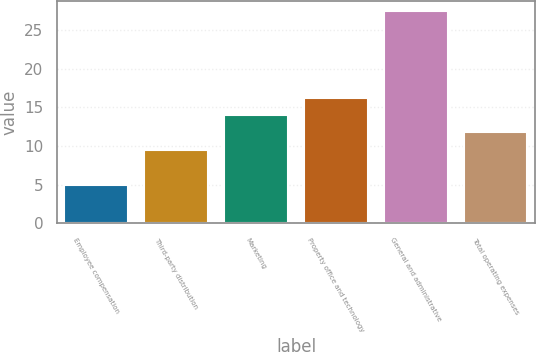Convert chart. <chart><loc_0><loc_0><loc_500><loc_500><bar_chart><fcel>Employee compensation<fcel>Third-party distribution<fcel>Marketing<fcel>Property office and technology<fcel>General and administrative<fcel>Total operating expenses<nl><fcel>4.9<fcel>9.5<fcel>14<fcel>16.25<fcel>27.4<fcel>11.75<nl></chart> 